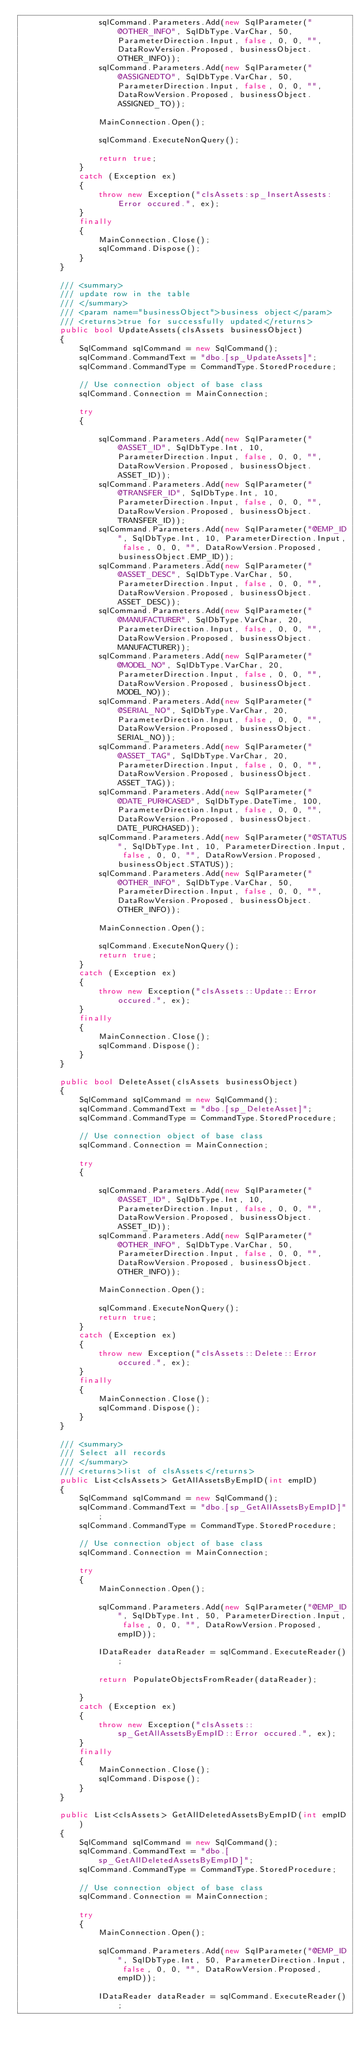<code> <loc_0><loc_0><loc_500><loc_500><_C#_>                sqlCommand.Parameters.Add(new SqlParameter("@OTHER_INFO", SqlDbType.VarChar, 50, ParameterDirection.Input, false, 0, 0, "", DataRowVersion.Proposed, businessObject.OTHER_INFO));
                sqlCommand.Parameters.Add(new SqlParameter("@ASSIGNEDTO", SqlDbType.VarChar, 50, ParameterDirection.Input, false, 0, 0, "", DataRowVersion.Proposed, businessObject.ASSIGNED_TO));

                MainConnection.Open();

                sqlCommand.ExecuteNonQuery();

                return true;
            }
            catch (Exception ex)
            {
                throw new Exception("clsAssets:sp_InsertAssests:Error occured.", ex);
            }
            finally
            {
                MainConnection.Close();
                sqlCommand.Dispose();
            }
        }

        /// <summary>
        /// update row in the table
        /// </summary>
        /// <param name="businessObject">business object</param>
        /// <returns>true for successfully updated</returns>
        public bool UpdateAssets(clsAssets businessObject)
        {
            SqlCommand sqlCommand = new SqlCommand();
            sqlCommand.CommandText = "dbo.[sp_UpdateAssets]";
            sqlCommand.CommandType = CommandType.StoredProcedure;

            // Use connection object of base class
            sqlCommand.Connection = MainConnection;

            try
            {

                sqlCommand.Parameters.Add(new SqlParameter("@ASSET_ID", SqlDbType.Int, 10, ParameterDirection.Input, false, 0, 0, "", DataRowVersion.Proposed, businessObject.ASSET_ID));
                sqlCommand.Parameters.Add(new SqlParameter("@TRANSFER_ID", SqlDbType.Int, 10, ParameterDirection.Input, false, 0, 0, "", DataRowVersion.Proposed, businessObject.TRANSFER_ID));
                sqlCommand.Parameters.Add(new SqlParameter("@EMP_ID", SqlDbType.Int, 10, ParameterDirection.Input, false, 0, 0, "", DataRowVersion.Proposed, businessObject.EMP_ID));
                sqlCommand.Parameters.Add(new SqlParameter("@ASSET_DESC", SqlDbType.VarChar, 50, ParameterDirection.Input, false, 0, 0, "", DataRowVersion.Proposed, businessObject.ASSET_DESC));
                sqlCommand.Parameters.Add(new SqlParameter("@MANUFACTURER", SqlDbType.VarChar, 20, ParameterDirection.Input, false, 0, 0, "", DataRowVersion.Proposed, businessObject.MANUFACTURER));
                sqlCommand.Parameters.Add(new SqlParameter("@MODEL_NO", SqlDbType.VarChar, 20, ParameterDirection.Input, false, 0, 0, "", DataRowVersion.Proposed, businessObject.MODEL_NO));
                sqlCommand.Parameters.Add(new SqlParameter("@SERIAL_NO", SqlDbType.VarChar, 20, ParameterDirection.Input, false, 0, 0, "", DataRowVersion.Proposed, businessObject.SERIAL_NO));
                sqlCommand.Parameters.Add(new SqlParameter("@ASSET_TAG", SqlDbType.VarChar, 20, ParameterDirection.Input, false, 0, 0, "", DataRowVersion.Proposed, businessObject.ASSET_TAG));
                sqlCommand.Parameters.Add(new SqlParameter("@DATE_PURHCASED", SqlDbType.DateTime, 100, ParameterDirection.Input, false, 0, 0, "", DataRowVersion.Proposed, businessObject.DATE_PURCHASED));
                sqlCommand.Parameters.Add(new SqlParameter("@STATUS", SqlDbType.Int, 10, ParameterDirection.Input, false, 0, 0, "", DataRowVersion.Proposed, businessObject.STATUS));
                sqlCommand.Parameters.Add(new SqlParameter("@OTHER_INFO", SqlDbType.VarChar, 50, ParameterDirection.Input, false, 0, 0, "", DataRowVersion.Proposed, businessObject.OTHER_INFO));

                MainConnection.Open();

                sqlCommand.ExecuteNonQuery();
                return true;
            }
            catch (Exception ex)
            {
                throw new Exception("clsAssets::Update::Error occured.", ex);
            }
            finally
            {
                MainConnection.Close();
                sqlCommand.Dispose();
            }
        }

        public bool DeleteAsset(clsAssets businessObject)
        {
            SqlCommand sqlCommand = new SqlCommand();
            sqlCommand.CommandText = "dbo.[sp_DeleteAsset]";
            sqlCommand.CommandType = CommandType.StoredProcedure;

            // Use connection object of base class
            sqlCommand.Connection = MainConnection;

            try
            {

                sqlCommand.Parameters.Add(new SqlParameter("@ASSET_ID", SqlDbType.Int, 10, ParameterDirection.Input, false, 0, 0, "", DataRowVersion.Proposed, businessObject.ASSET_ID));
                sqlCommand.Parameters.Add(new SqlParameter("@OTHER_INFO", SqlDbType.VarChar, 50, ParameterDirection.Input, false, 0, 0, "", DataRowVersion.Proposed, businessObject.OTHER_INFO));

                MainConnection.Open();

                sqlCommand.ExecuteNonQuery();
                return true;
            }
            catch (Exception ex)
            {
                throw new Exception("clsAssets::Delete::Error occured.", ex);
            }
            finally
            {
                MainConnection.Close();
                sqlCommand.Dispose();
            }
        }

        /// <summary>
        /// Select all records
        /// </summary>
        /// <returns>list of clsAssets</returns>
        public List<clsAssets> GetAllAssetsByEmpID(int empID)
        {
            SqlCommand sqlCommand = new SqlCommand();
            sqlCommand.CommandText = "dbo.[sp_GetAllAssetsByEmpID]";
            sqlCommand.CommandType = CommandType.StoredProcedure;

            // Use connection object of base class
            sqlCommand.Connection = MainConnection;

            try
            {
                MainConnection.Open();

                sqlCommand.Parameters.Add(new SqlParameter("@EMP_ID", SqlDbType.Int, 50, ParameterDirection.Input, false, 0, 0, "", DataRowVersion.Proposed, empID));

                IDataReader dataReader = sqlCommand.ExecuteReader();

                return PopulateObjectsFromReader(dataReader);

            }
            catch (Exception ex)
            {
                throw new Exception("clsAssets::sp_GetAllAssetsByEmpID::Error occured.", ex);
            }
            finally
            {
                MainConnection.Close();
                sqlCommand.Dispose();
            }
        }

        public List<clsAssets> GetAllDeletedAssetsByEmpID(int empID)
        {
            SqlCommand sqlCommand = new SqlCommand();
            sqlCommand.CommandText = "dbo.[sp_GetAllDeletedAssetsByEmpID]";
            sqlCommand.CommandType = CommandType.StoredProcedure;

            // Use connection object of base class
            sqlCommand.Connection = MainConnection;

            try
            {
                MainConnection.Open();

                sqlCommand.Parameters.Add(new SqlParameter("@EMP_ID", SqlDbType.Int, 50, ParameterDirection.Input, false, 0, 0, "", DataRowVersion.Proposed, empID));

                IDataReader dataReader = sqlCommand.ExecuteReader();
</code> 